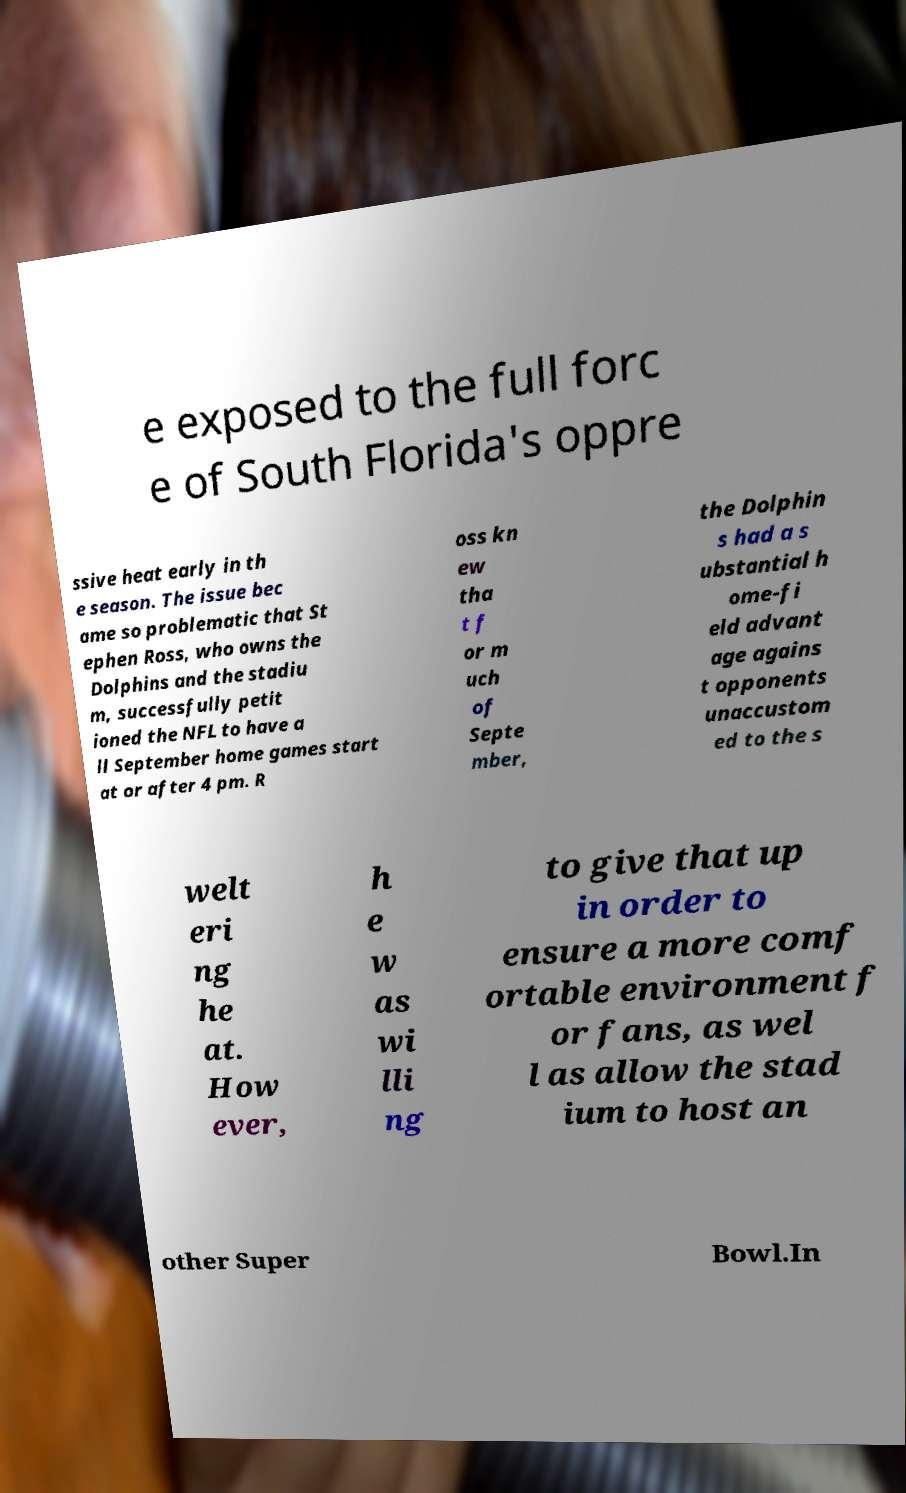Could you assist in decoding the text presented in this image and type it out clearly? e exposed to the full forc e of South Florida's oppre ssive heat early in th e season. The issue bec ame so problematic that St ephen Ross, who owns the Dolphins and the stadiu m, successfully petit ioned the NFL to have a ll September home games start at or after 4 pm. R oss kn ew tha t f or m uch of Septe mber, the Dolphin s had a s ubstantial h ome-fi eld advant age agains t opponents unaccustom ed to the s welt eri ng he at. How ever, h e w as wi lli ng to give that up in order to ensure a more comf ortable environment f or fans, as wel l as allow the stad ium to host an other Super Bowl.In 